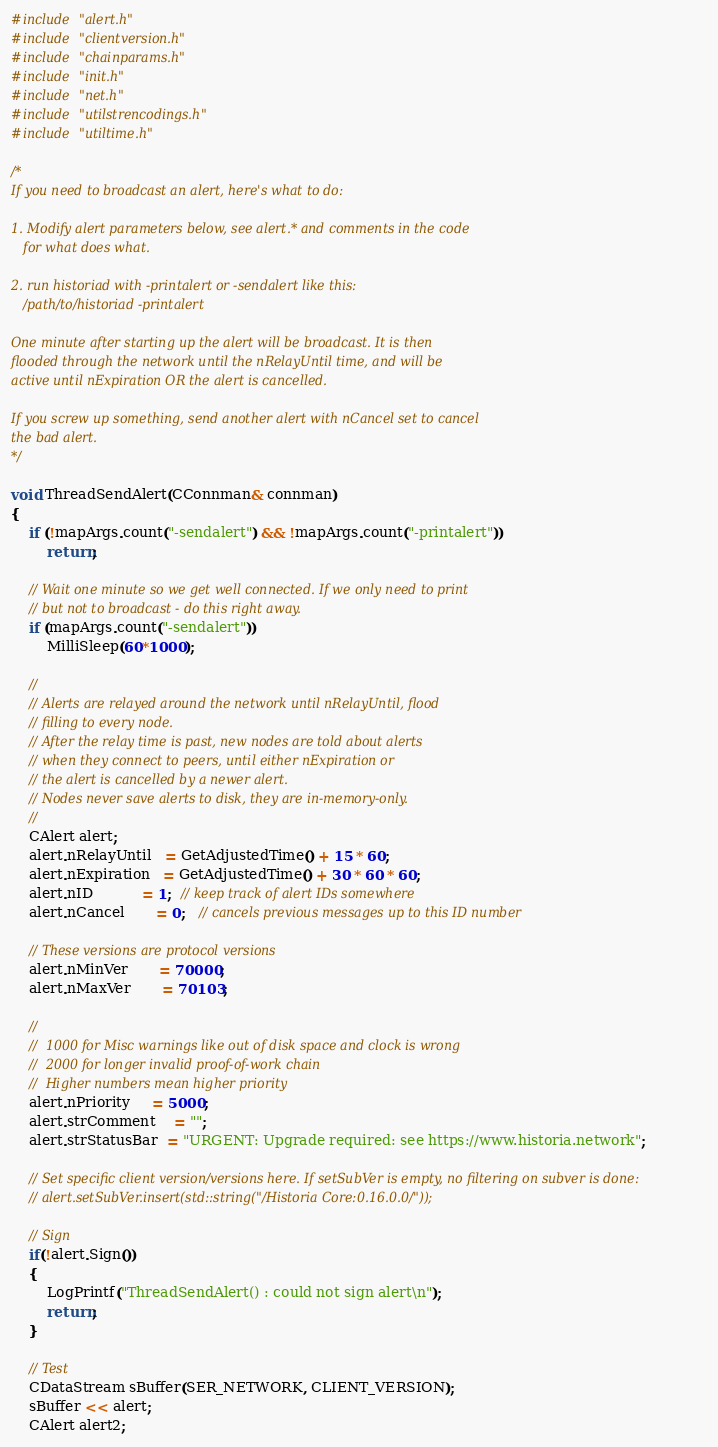Convert code to text. <code><loc_0><loc_0><loc_500><loc_500><_C++_>#include "alert.h"
#include "clientversion.h"
#include "chainparams.h"
#include "init.h"
#include "net.h"
#include "utilstrencodings.h"
#include "utiltime.h"

/*
If you need to broadcast an alert, here's what to do:

1. Modify alert parameters below, see alert.* and comments in the code
   for what does what.

2. run historiad with -printalert or -sendalert like this:
   /path/to/historiad -printalert

One minute after starting up the alert will be broadcast. It is then
flooded through the network until the nRelayUntil time, and will be
active until nExpiration OR the alert is cancelled.

If you screw up something, send another alert with nCancel set to cancel
the bad alert.
*/

void ThreadSendAlert(CConnman& connman)
{
    if (!mapArgs.count("-sendalert") && !mapArgs.count("-printalert"))
        return;

    // Wait one minute so we get well connected. If we only need to print
    // but not to broadcast - do this right away.
    if (mapArgs.count("-sendalert"))
        MilliSleep(60*1000);

    //
    // Alerts are relayed around the network until nRelayUntil, flood
    // filling to every node.
    // After the relay time is past, new nodes are told about alerts
    // when they connect to peers, until either nExpiration or
    // the alert is cancelled by a newer alert.
    // Nodes never save alerts to disk, they are in-memory-only.
    //
    CAlert alert;
    alert.nRelayUntil   = GetAdjustedTime() + 15 * 60;
    alert.nExpiration   = GetAdjustedTime() + 30 * 60 * 60;
    alert.nID           = 1;  // keep track of alert IDs somewhere
    alert.nCancel       = 0;   // cancels previous messages up to this ID number

    // These versions are protocol versions
    alert.nMinVer       = 70000;
    alert.nMaxVer       = 70103;

    //
    //  1000 for Misc warnings like out of disk space and clock is wrong
    //  2000 for longer invalid proof-of-work chain
    //  Higher numbers mean higher priority
    alert.nPriority     = 5000;
    alert.strComment    = "";
    alert.strStatusBar  = "URGENT: Upgrade required: see https://www.historia.network";

    // Set specific client version/versions here. If setSubVer is empty, no filtering on subver is done:
    // alert.setSubVer.insert(std::string("/Historia Core:0.16.0.0/"));

    // Sign
    if(!alert.Sign())
    {
        LogPrintf("ThreadSendAlert() : could not sign alert\n");
        return;
    }

    // Test
    CDataStream sBuffer(SER_NETWORK, CLIENT_VERSION);
    sBuffer << alert;
    CAlert alert2;</code> 